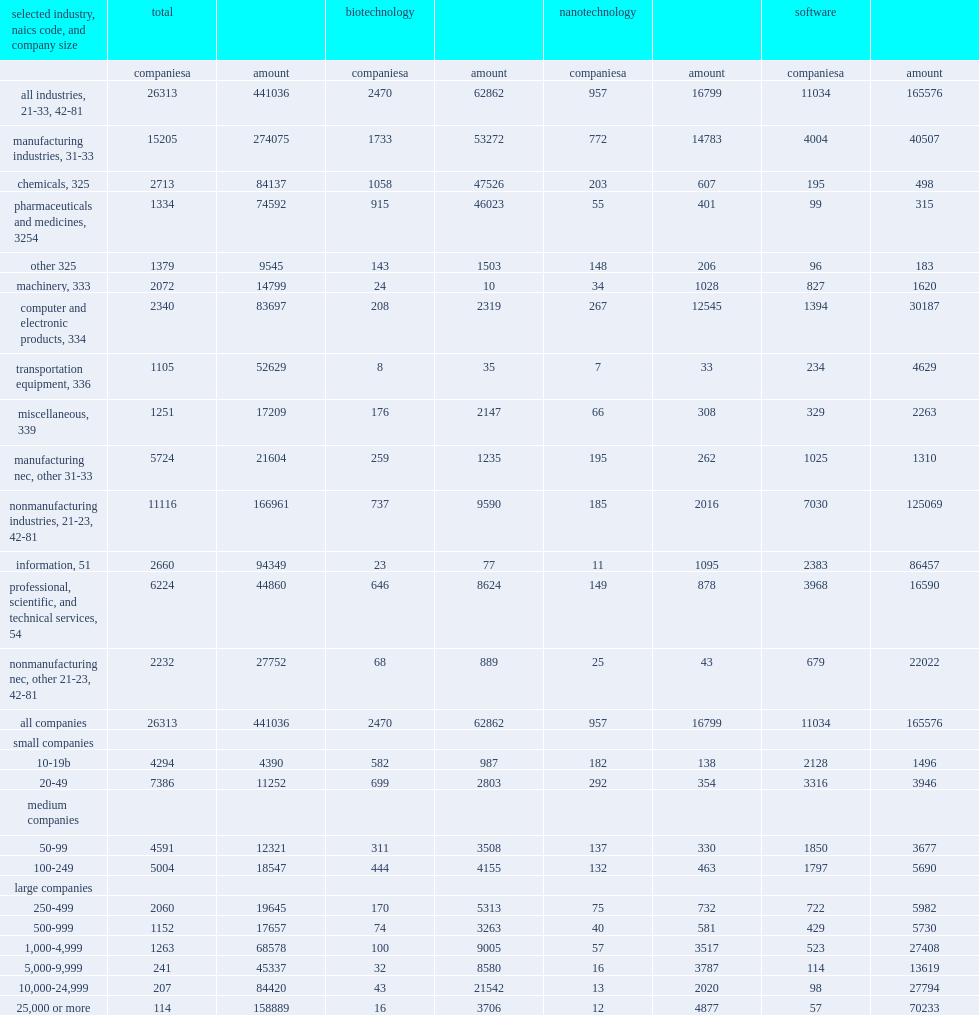Could you parse the entire table as a dict? {'header': ['selected industry, naics code, and company size', 'total', '', 'biotechnology', '', 'nanotechnology', '', 'software', ''], 'rows': [['', 'companiesa', 'amount', 'companiesa', 'amount', 'companiesa', 'amount', 'companiesa', 'amount'], ['all industries, 21-33, 42-81', '26313', '441036', '2470', '62862', '957', '16799', '11034', '165576'], ['manufacturing industries, 31-33', '15205', '274075', '1733', '53272', '772', '14783', '4004', '40507'], ['chemicals, 325', '2713', '84137', '1058', '47526', '203', '607', '195', '498'], ['pharmaceuticals and medicines, 3254', '1334', '74592', '915', '46023', '55', '401', '99', '315'], ['other 325', '1379', '9545', '143', '1503', '148', '206', '96', '183'], ['machinery, 333', '2072', '14799', '24', '10', '34', '1028', '827', '1620'], ['computer and electronic products, 334', '2340', '83697', '208', '2319', '267', '12545', '1394', '30187'], ['transportation equipment, 336', '1105', '52629', '8', '35', '7', '33', '234', '4629'], ['miscellaneous, 339', '1251', '17209', '176', '2147', '66', '308', '329', '2263'], ['manufacturing nec, other 31-33', '5724', '21604', '259', '1235', '195', '262', '1025', '1310'], ['nonmanufacturing industries, 21-23, 42-81', '11116', '166961', '737', '9590', '185', '2016', '7030', '125069'], ['information, 51', '2660', '94349', '23', '77', '11', '1095', '2383', '86457'], ['professional, scientific, and technical services, 54', '6224', '44860', '646', '8624', '149', '878', '3968', '16590'], ['nonmanufacturing nec, other 21-23, 42-81', '2232', '27752', '68', '889', '25', '43', '679', '22022'], ['all companies', '26313', '441036', '2470', '62862', '957', '16799', '11034', '165576'], ['small companies', '', '', '', '', '', '', '', ''], ['10-19b', '4294', '4390', '582', '987', '182', '138', '2128', '1496'], ['20-49', '7386', '11252', '699', '2803', '292', '354', '3316', '3946'], ['medium companies', '', '', '', '', '', '', '', ''], ['50-99', '4591', '12321', '311', '3508', '137', '330', '1850', '3677'], ['100-249', '5004', '18547', '444', '4155', '132', '463', '1797', '5690'], ['large companies', '', '', '', '', '', '', '', ''], ['250-499', '2060', '19645', '170', '5313', '75', '732', '722', '5982'], ['500-999', '1152', '17657', '74', '3263', '40', '581', '429', '5730'], ['1,000-4,999', '1263', '68578', '100', '9005', '57', '3517', '523', '27408'], ['5,000-9,999', '241', '45337', '32', '8580', '16', '3787', '114', '13619'], ['10,000-24,999', '207', '84420', '43', '21542', '13', '2020', '98', '27794'], ['25,000 or more', '114', '158889', '16', '3706', '12', '4877', '57', '70233']]} How many million dollars of software r&d did businesses perform in 2018? 165576.0. Of the approximately 26,000 companies with 10 or more employees that performed r&d in 2018, how many percentage points of companies are estimated to have performed software r&d? 0.419336. 